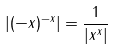<formula> <loc_0><loc_0><loc_500><loc_500>| ( - x ) ^ { - x } | = \frac { 1 } { | x ^ { x } | }</formula> 